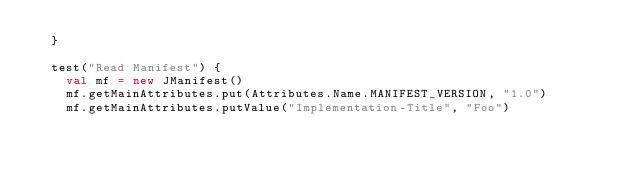<code> <loc_0><loc_0><loc_500><loc_500><_Scala_>  }

  test("Read Manifest") {
    val mf = new JManifest()
    mf.getMainAttributes.put(Attributes.Name.MANIFEST_VERSION, "1.0")
    mf.getMainAttributes.putValue("Implementation-Title", "Foo")</code> 